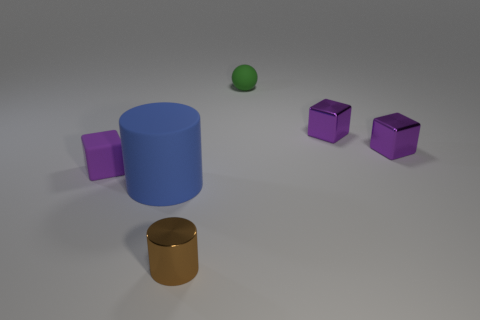What size is the green ball?
Provide a short and direct response. Small. Are the purple block that is on the left side of the brown metallic cylinder and the brown cylinder made of the same material?
Your response must be concise. No. What number of small brown metallic things are there?
Give a very brief answer. 1. How many objects are blue rubber spheres or tiny purple shiny objects?
Ensure brevity in your answer.  2. There is a metallic object that is in front of the small purple cube left of the tiny brown metallic cylinder; what number of small brown cylinders are on the left side of it?
Ensure brevity in your answer.  0. Is there any other thing that has the same color as the metal cylinder?
Make the answer very short. No. Is the color of the cylinder that is behind the tiny brown shiny cylinder the same as the small matte object in front of the green matte object?
Ensure brevity in your answer.  No. Are there more blue things that are in front of the large matte cylinder than blue cylinders that are on the right side of the brown cylinder?
Your answer should be compact. No. What material is the small sphere?
Offer a terse response. Rubber. The small thing that is to the left of the blue cylinder that is in front of the thing left of the rubber cylinder is what shape?
Provide a short and direct response. Cube. 